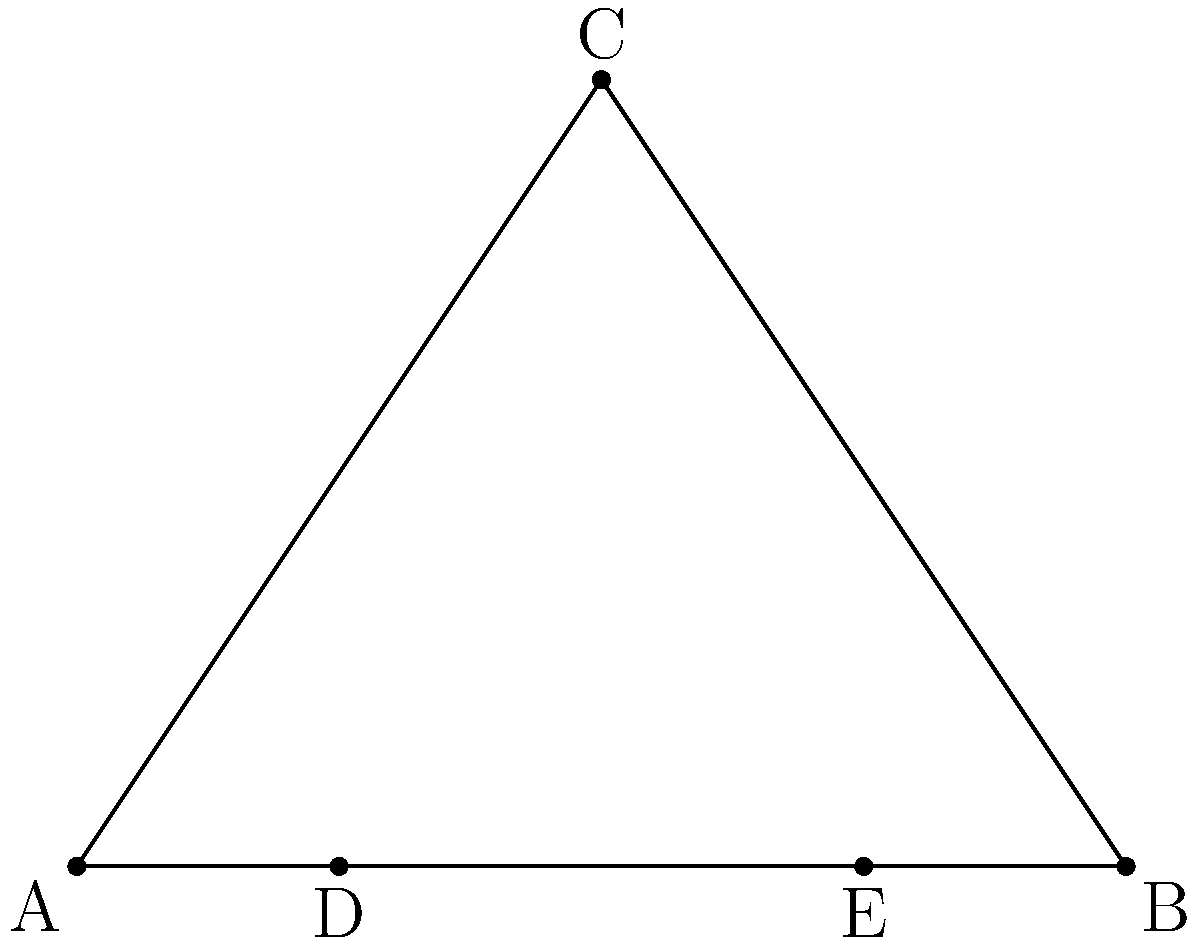In a traditional Nordic weaving loom, the frame forms an isosceles triangle ABC with base AB. Points D and E are located on AB such that AD:DB = BE:EA = 1:3. If the angle at vertex C is 60°, what is the ratio of DE to AB? Let's approach this step-by-step:

1) In an isosceles triangle with a 60° angle at the apex, the base angles are each 60° as well. This makes ABC an equilateral triangle.

2) In an equilateral triangle, the ratio of any median to a side is $\frac{\sqrt{3}}{2}$.

3) Points D and E divide AB in the ratio 1:3:1. So, AD = $\frac{1}{5}$AB, DE = $\frac{3}{5}$AB, and EB = $\frac{1}{5}$AB.

4) The ratio we're looking for is DE:AB = $\frac{3}{5}$:1 = 3:5.

5) To simplify this ratio, we can divide both terms by their greatest common divisor, which is 1.

Therefore, the simplified ratio of DE to AB is 3:5.
Answer: 3:5 